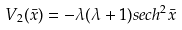Convert formula to latex. <formula><loc_0><loc_0><loc_500><loc_500>V _ { 2 } ( \bar { x } ) = - \lambda ( \lambda + 1 ) s e c h ^ { 2 } \bar { x }</formula> 